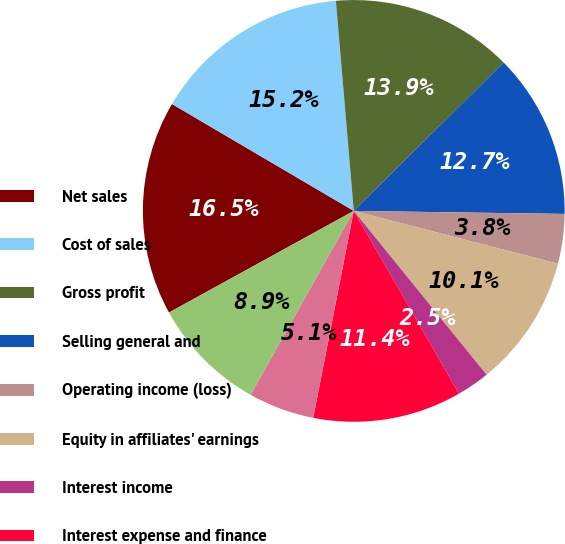Convert chart to OTSL. <chart><loc_0><loc_0><loc_500><loc_500><pie_chart><fcel>Net sales<fcel>Cost of sales<fcel>Gross profit<fcel>Selling general and<fcel>Operating income (loss)<fcel>Equity in affiliates' earnings<fcel>Interest income<fcel>Interest expense and finance<fcel>Earnings (loss) before income<fcel>noncontrolling interest<nl><fcel>16.46%<fcel>15.19%<fcel>13.92%<fcel>12.66%<fcel>3.8%<fcel>10.13%<fcel>2.53%<fcel>11.39%<fcel>5.06%<fcel>8.86%<nl></chart> 